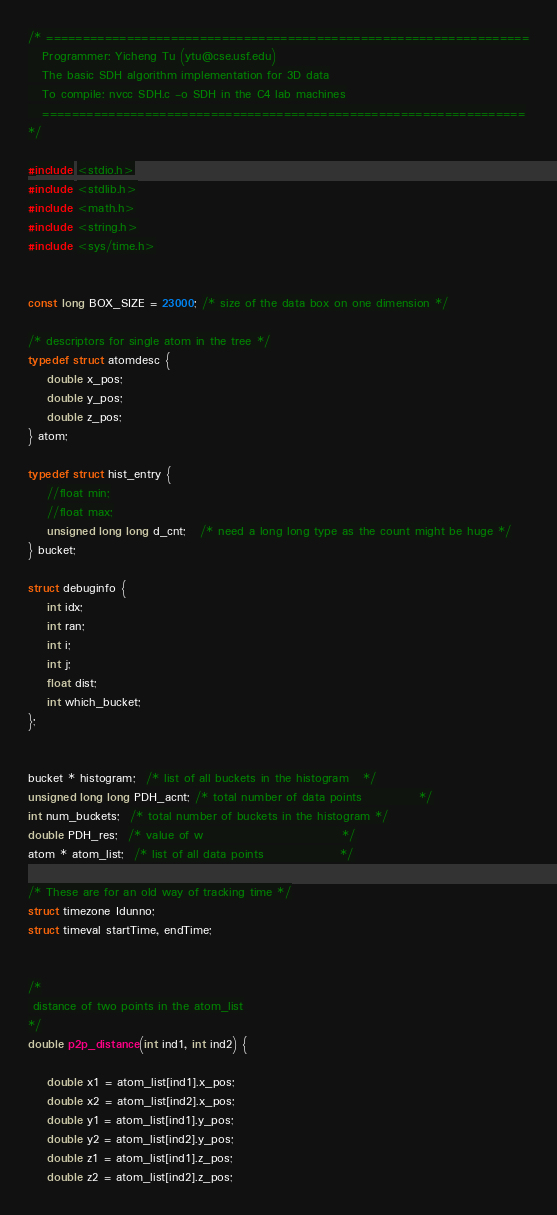Convert code to text. <code><loc_0><loc_0><loc_500><loc_500><_Cuda_>/* ==================================================================
   Programmer: Yicheng Tu (ytu@cse.usf.edu)
   The basic SDH algorithm implementation for 3D data
   To compile: nvcc SDH.c -o SDH in the C4 lab machines
   ==================================================================
*/

#include <stdio.h>
#include <stdlib.h>
#include <math.h>
#include <string.h>
#include <sys/time.h>


const long BOX_SIZE = 23000; /* size of the data box on one dimension */

/* descriptors for single atom in the tree */
typedef struct atomdesc {
    double x_pos;
    double y_pos;
    double z_pos;
} atom;

typedef struct hist_entry {
    //float min;
    //float max;
    unsigned long long d_cnt;   /* need a long long type as the count might be huge */
} bucket;

struct debuginfo {
    int idx;
    int ran;
    int i;
    int j;
    float dist;
    int which_bucket;
};


bucket * histogram;  /* list of all buckets in the histogram   */
unsigned long long PDH_acnt; /* total number of data points            */
int num_buckets;  /* total number of buckets in the histogram */
double PDH_res;  /* value of w                             */
atom * atom_list;  /* list of all data points                */

/* These are for an old way of tracking time */
struct timezone Idunno;
struct timeval startTime, endTime;


/*
 distance of two points in the atom_list
*/
double p2p_distance(int ind1, int ind2) {

    double x1 = atom_list[ind1].x_pos;
    double x2 = atom_list[ind2].x_pos;
    double y1 = atom_list[ind1].y_pos;
    double y2 = atom_list[ind2].y_pos;
    double z1 = atom_list[ind1].z_pos;
    double z2 = atom_list[ind2].z_pos;
</code> 